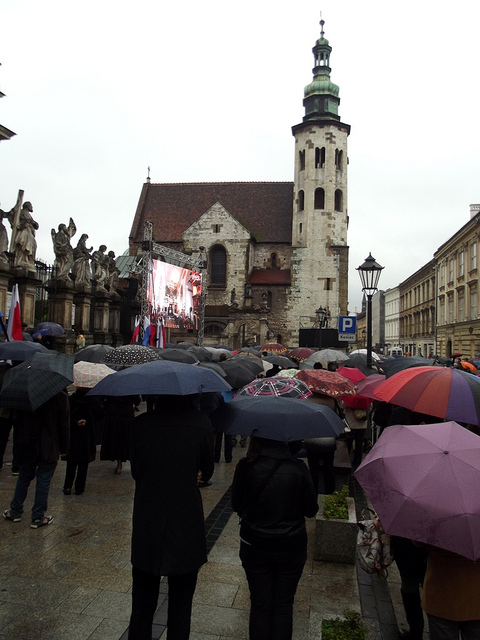Please transcribe the text information in this image. P 